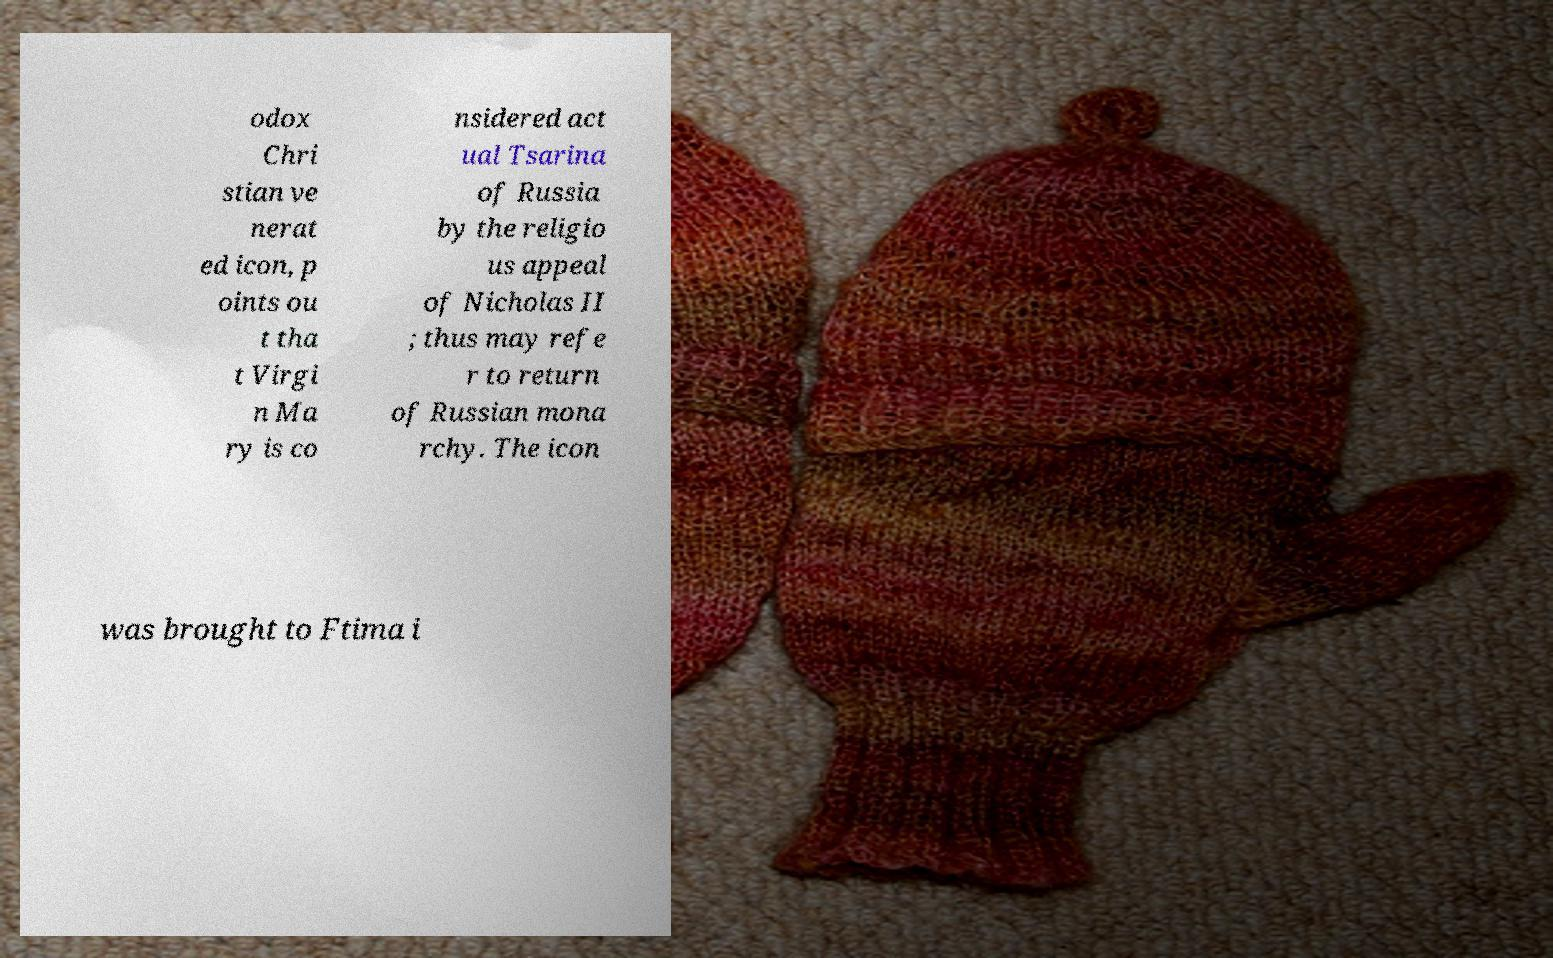Could you extract and type out the text from this image? odox Chri stian ve nerat ed icon, p oints ou t tha t Virgi n Ma ry is co nsidered act ual Tsarina of Russia by the religio us appeal of Nicholas II ; thus may refe r to return of Russian mona rchy. The icon was brought to Ftima i 